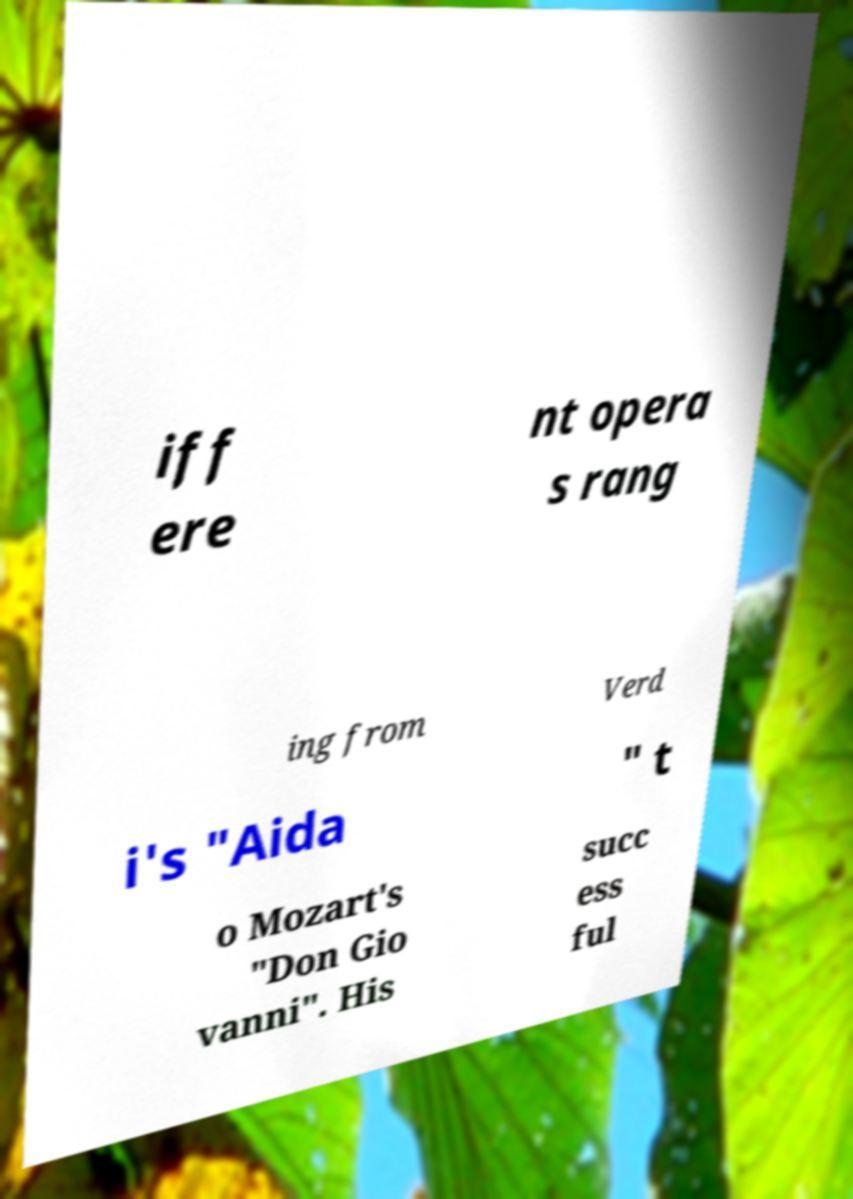Can you read and provide the text displayed in the image?This photo seems to have some interesting text. Can you extract and type it out for me? iff ere nt opera s rang ing from Verd i's "Aida " t o Mozart's "Don Gio vanni". His succ ess ful 